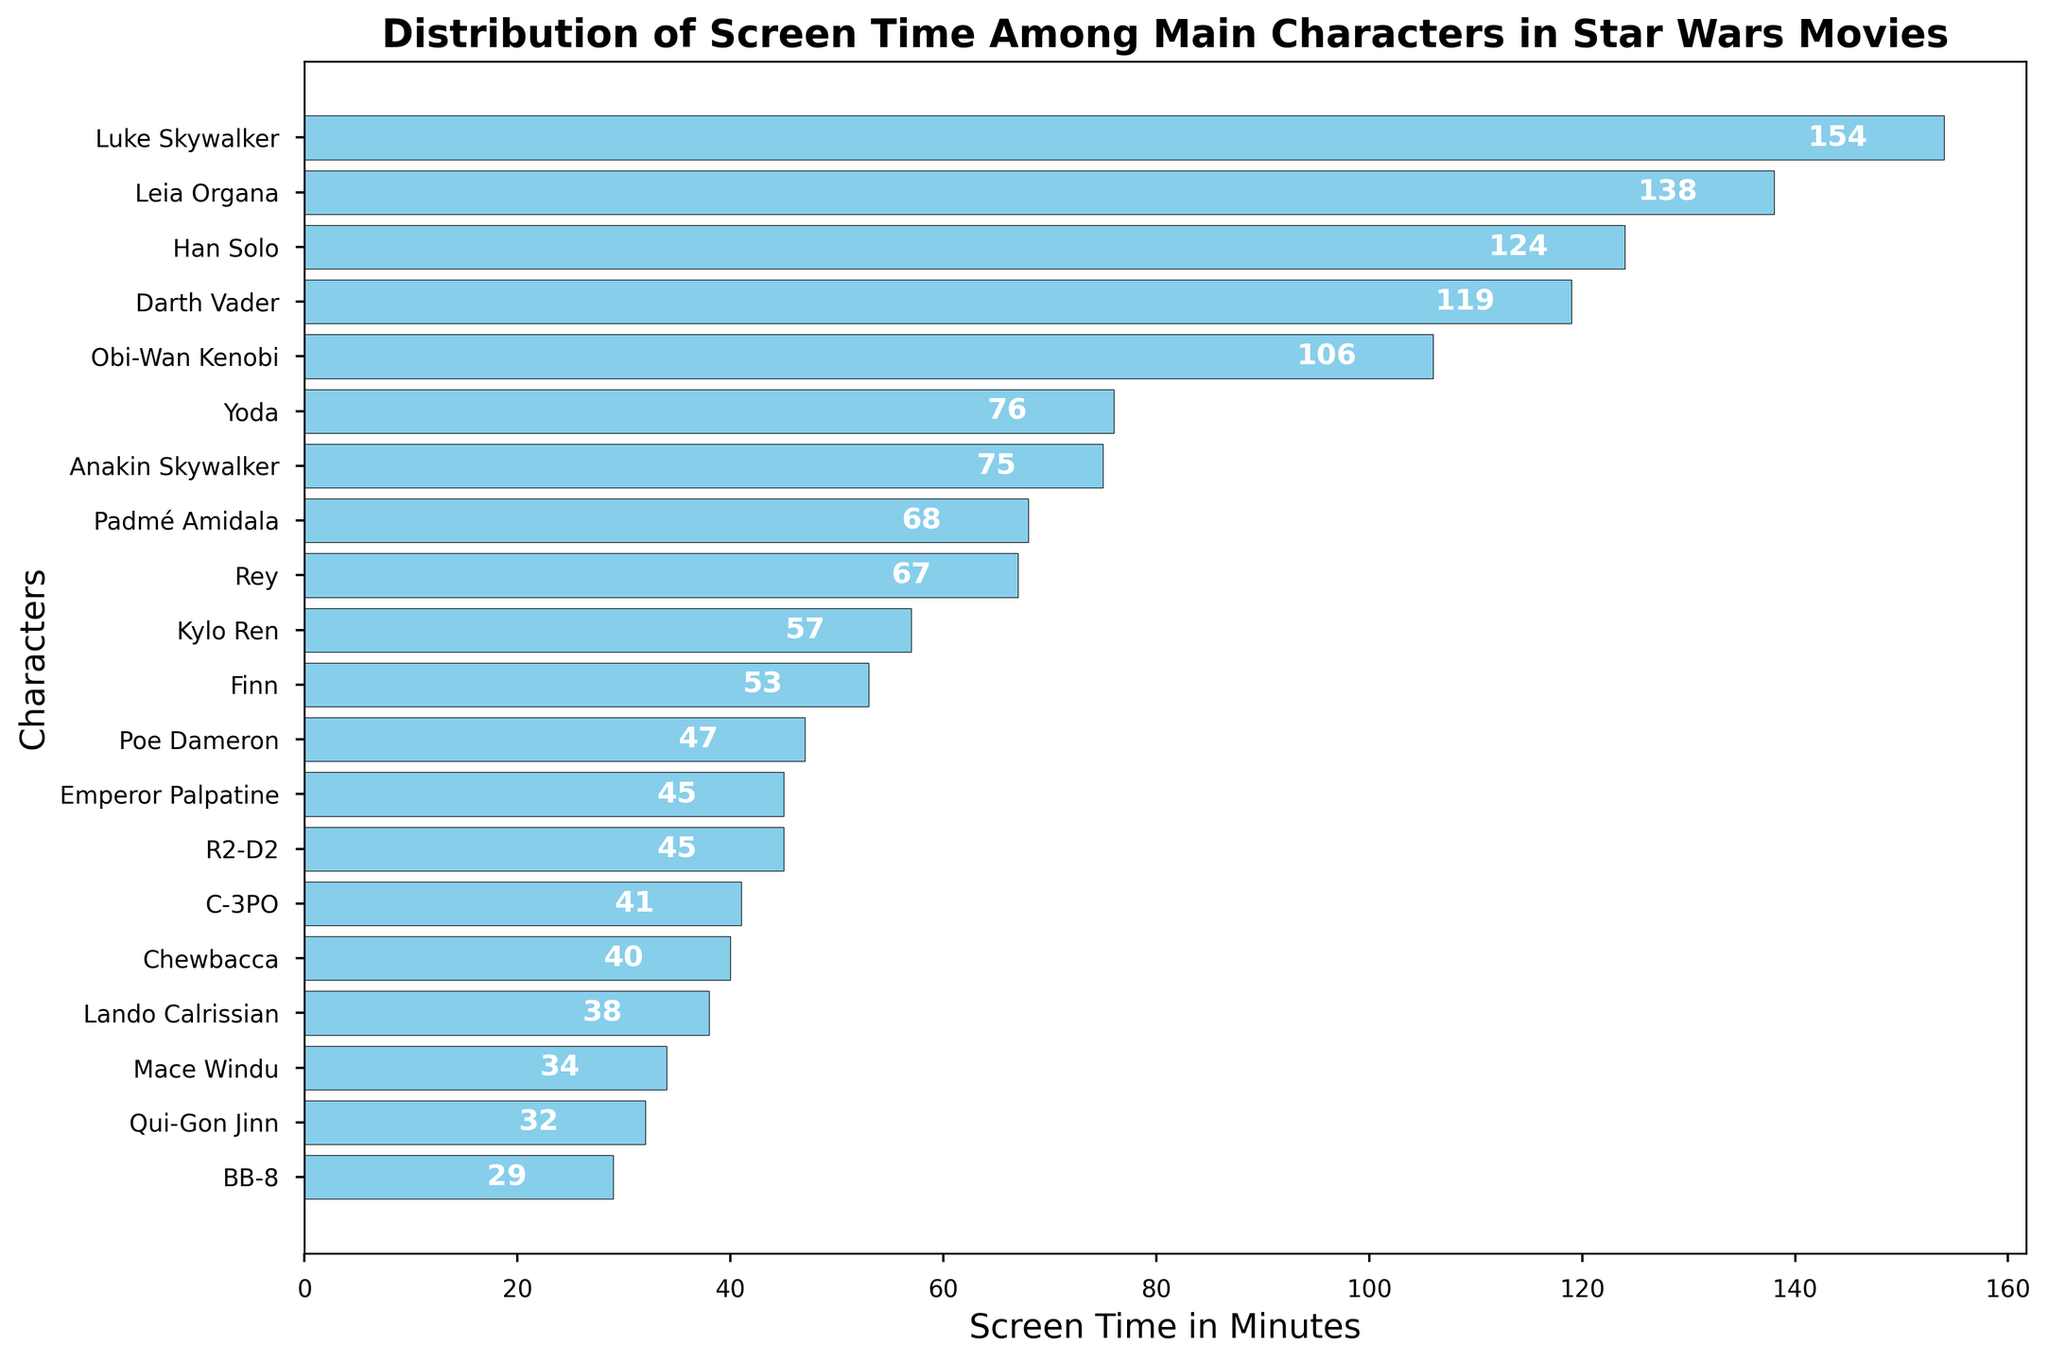Which character has the highest screen time? The bar at the top of the chart represents the character with the most screen time. Luke Skywalker is positioned at the top with 154 minutes.
Answer: Luke Skywalker How many minutes of screen time do Leia Organa and Han Solo have together? Leia Organa has 138 minutes and Han Solo has 124 minutes. Adding them together, 138 + 124 = 262 minutes.
Answer: 262 minutes Is Darth Vader’s screen time greater than Anakin Skywalker’s? Observe the lengths of the bars for Darth Vader and Anakin Skywalker. Darth Vader has 119 minutes, while Anakin Skywalker has 75 minutes. 119 is greater than 75.
Answer: Yes Who has more screen time, Yoda or Rey? Compare the lengths of the bars for Yoda and Rey. Yoda has 76 minutes and Rey has 67 minutes. 76 is more than 67.
Answer: Yoda What's the combined screen time of the characters with the shortest and longest screen time? The character with the shortest screen time is BB-8 with 29 minutes, and the character with the longest screen time is Luke Skywalker with 154 minutes. Adding them together, 29 + 154 = 183 minutes.
Answer: 183 minutes Which characters have the same amount of screen time? Look for characters with bars of equal length. Emperor Palpatine and R2-D2 both have 45 minutes of screen time.
Answer: Emperor Palpatine and R2-D2 Is the total screen time of the original trilogy (Luke Skywalker, Leia Organa, and Han Solo) greater than the combined screen time of Rey, Finn, and Poe Dameron? Calculate the total screen time of the original trilogy: Luke Skywalker (154) + Leia Organa (138) + Han Solo (124) = 416 minutes. Then, for Rey, Finn, and Poe Dameron: Rey (67) + Finn (53) + Poe Dameron (47) = 167 minutes. 416 is greater than 167.
Answer: Yes Do Kylo Ren and Finn have more or less combined screen time than Obi-Wan Kenobi? Calculate and compare: Kylo Ren (57) + Finn (53) = 110 minutes. Compare this with Obi-Wan Kenobi's 106 minutes. 110 is more than 106.
Answer: More Which character from the original trilogy has the least screen time? Look at the original trilogy characters, which include Luke Skywalker, Leia Organa, Han Solo, and compare. Han Solo has 124, Leia Organa has 138, and Luke Skywalker has 154; thus, Han Solo has the least screen time among them.
Answer: Han Solo 